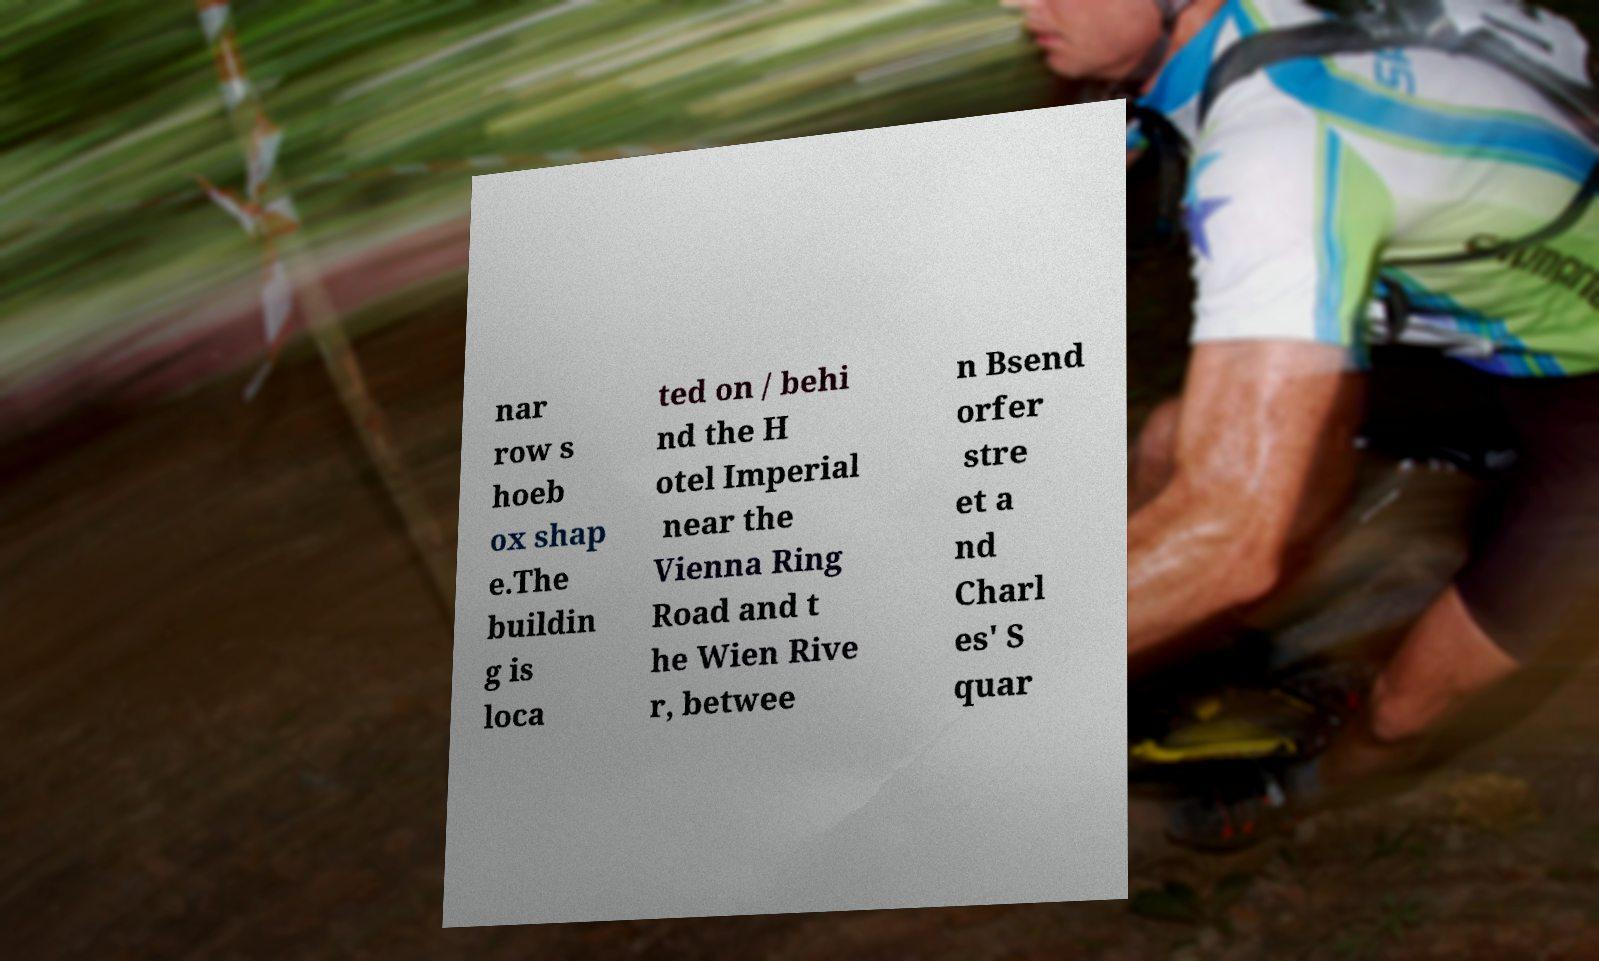There's text embedded in this image that I need extracted. Can you transcribe it verbatim? nar row s hoeb ox shap e.The buildin g is loca ted on / behi nd the H otel Imperial near the Vienna Ring Road and t he Wien Rive r, betwee n Bsend orfer stre et a nd Charl es' S quar 